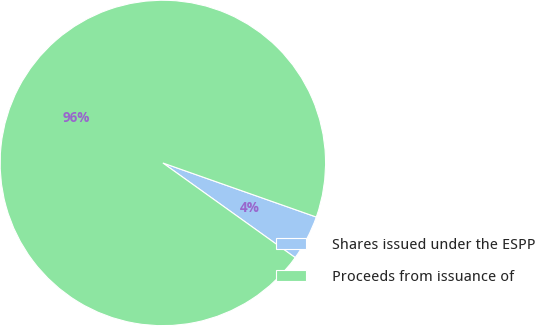Convert chart. <chart><loc_0><loc_0><loc_500><loc_500><pie_chart><fcel>Shares issued under the ESPP<fcel>Proceeds from issuance of<nl><fcel>4.49%<fcel>95.51%<nl></chart> 